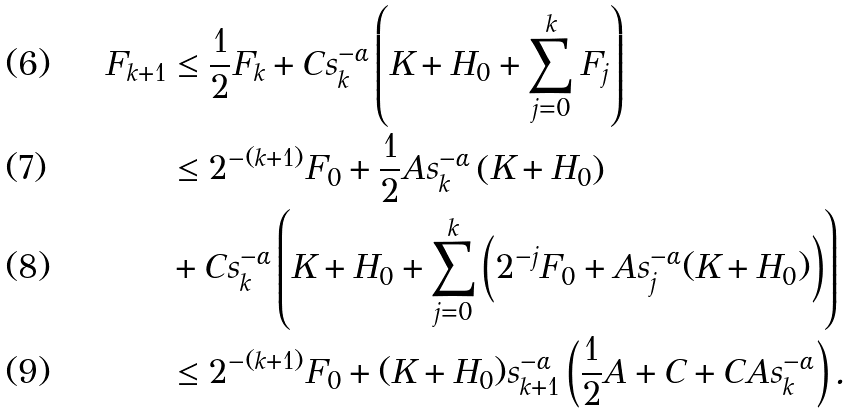<formula> <loc_0><loc_0><loc_500><loc_500>F _ { k + 1 } & \leq \frac { 1 } { 2 } F _ { k } + C s ^ { - \alpha } _ { k } \left ( K + H _ { 0 } + \sum _ { j = 0 } ^ { k } F _ { j } \right ) \\ & \leq 2 ^ { - ( k + 1 ) } F _ { 0 } + \frac { 1 } { 2 } A s _ { k } ^ { - \alpha } \left ( K + H _ { 0 } \right ) \\ & + C s _ { k } ^ { - \alpha } \left ( K + H _ { 0 } + \sum _ { j = 0 } ^ { k } \left ( 2 ^ { - j } F _ { 0 } + A s _ { j } ^ { - \alpha } ( K + H _ { 0 } ) \right ) \right ) \\ & \leq 2 ^ { - ( k + 1 ) } F _ { 0 } + ( K + H _ { 0 } ) s _ { k + 1 } ^ { - \alpha } \left ( \frac { 1 } { 2 } A + C + C A s _ { k } ^ { - \alpha } \right ) .</formula> 